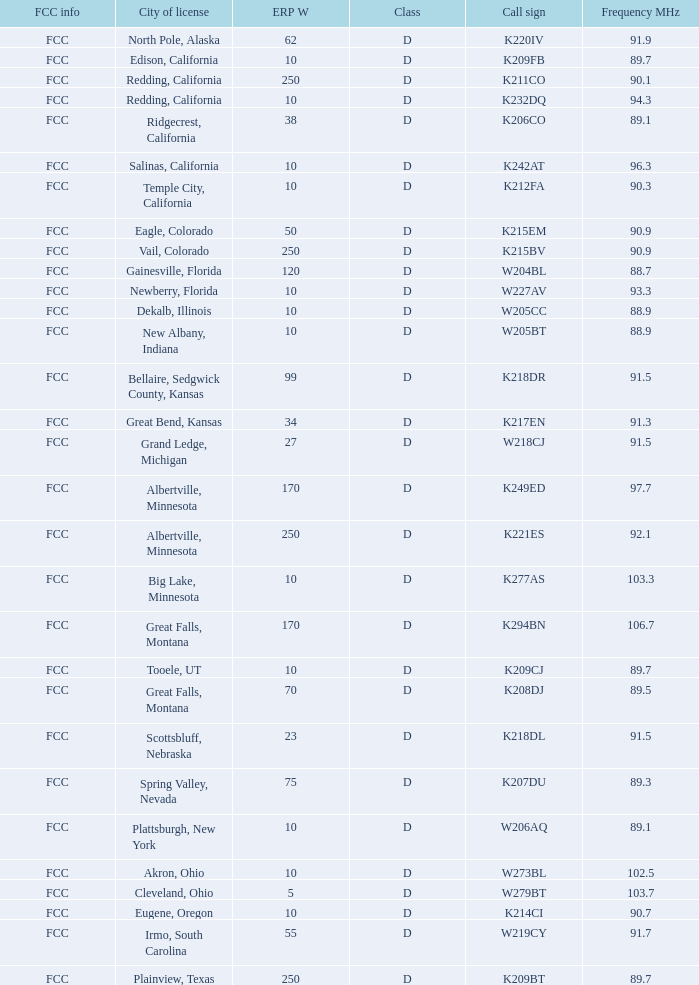Which class is associated with a translator having 10 erp w and a w273bl call sign? D. 